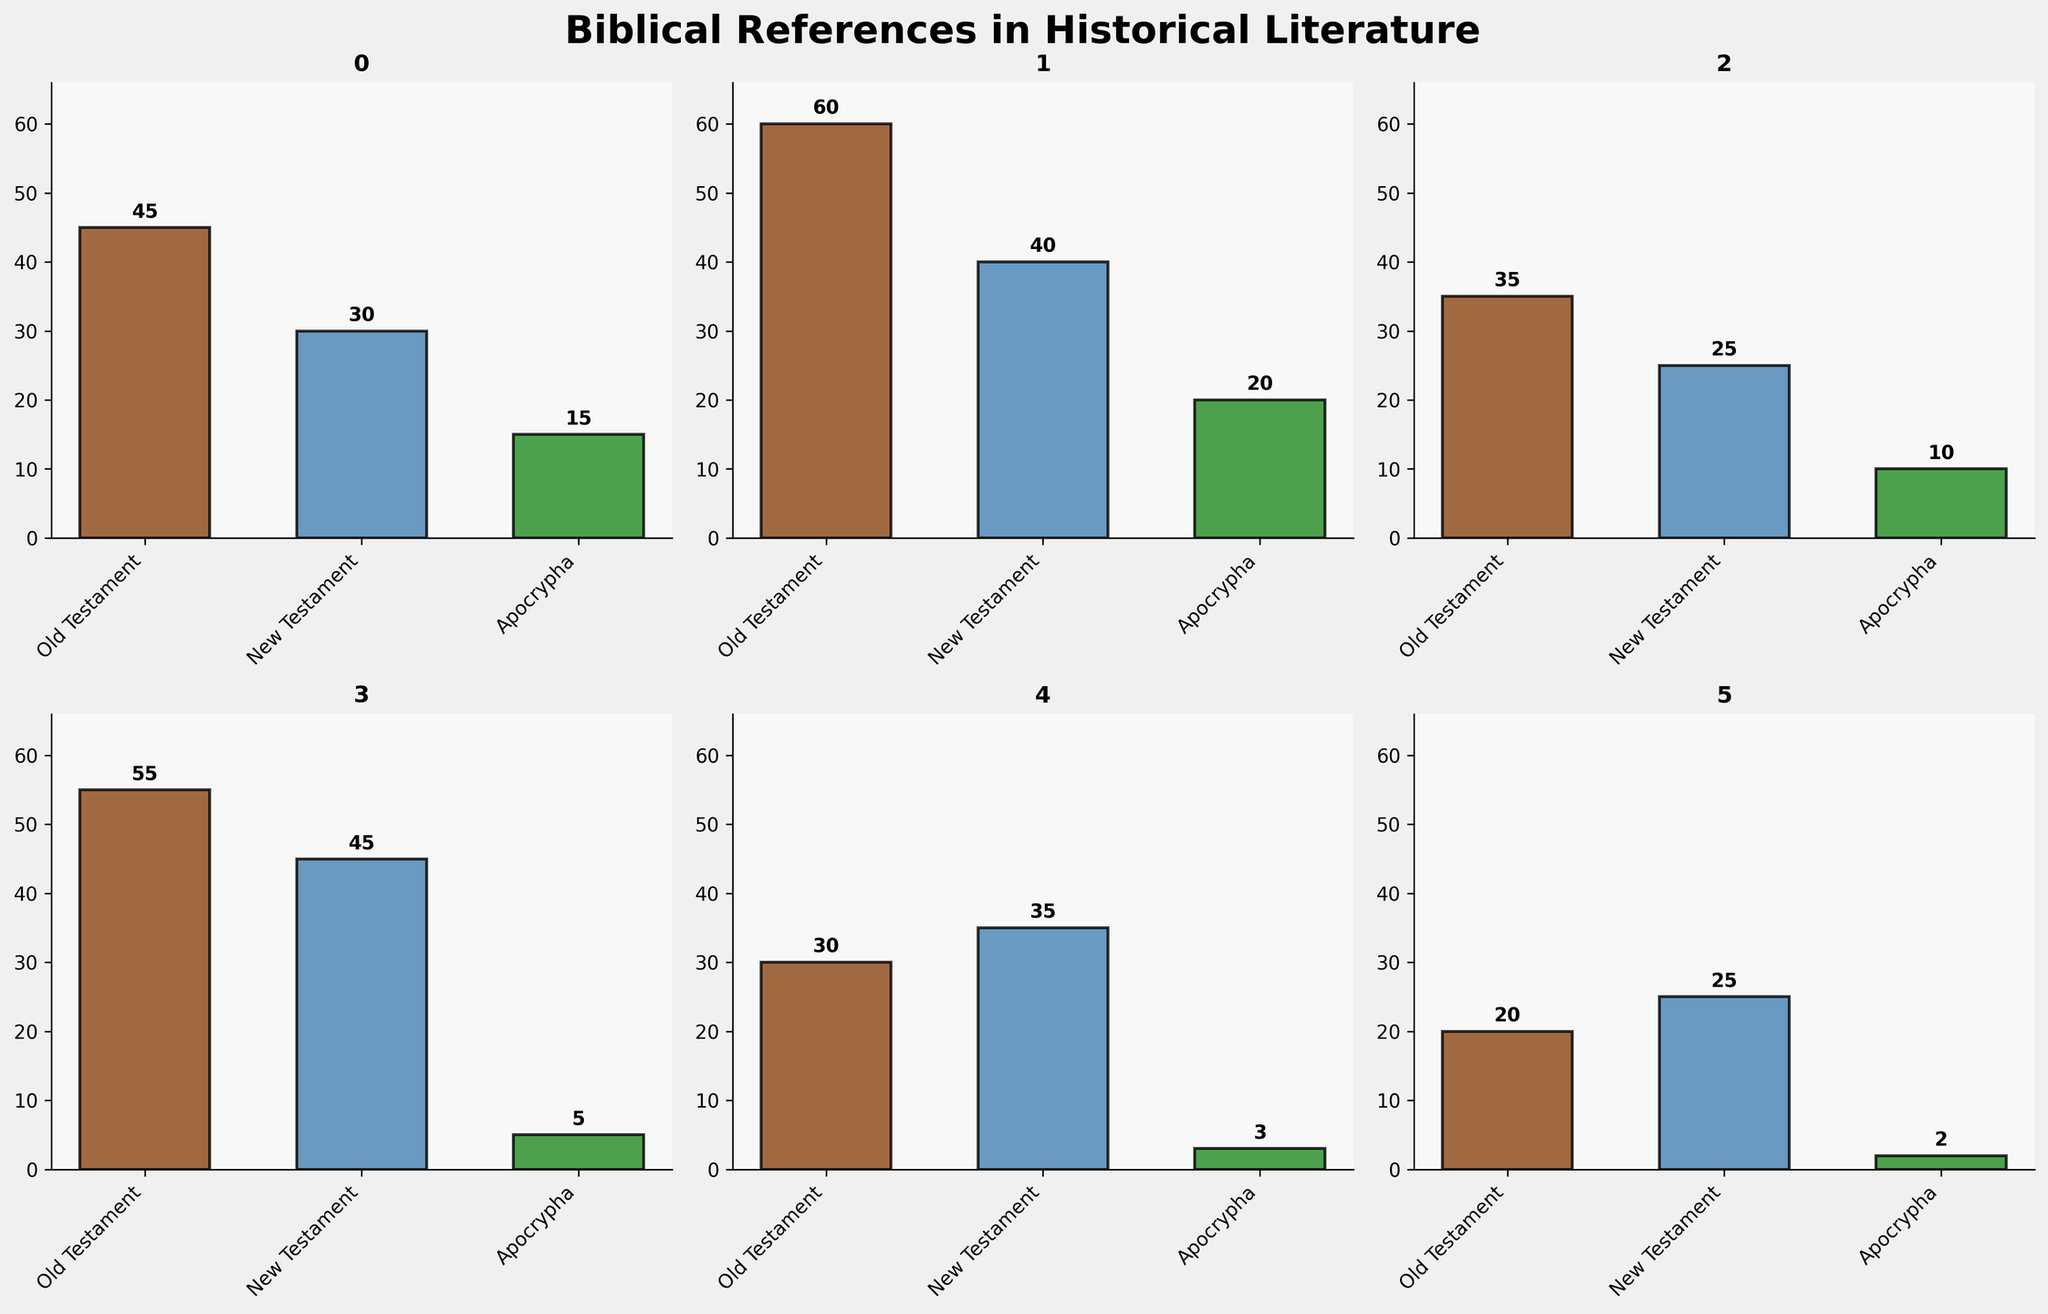Which time period has the highest frequency of Old Testament references? The bar chart shows that the Renaissance period has the highest frequency of Old Testament references with a value of 60.
Answer: Renaissance (1500-1600) Which book group has the lowest reference frequency in the Contemporary period? By examining the subplots for the Contemporary period, the Apocrypha has the lowest reference frequency with a value of 2.
Answer: Apocrypha How does the frequency of New Testament references in the Enlightenment period compare to the frequency in the Victorian Era? The bar charts show that the New Testament references have a frequency of 25 in the Enlightenment period and 45 in the Victorian Era, making it higher in the Victorian Era.
Answer: Victorian Era What is the average frequency of all biblical references in the Modern period? In the Modern period, the frequencies are Old Testament: 30, New Testament: 35, Apocrypha: 3. Summing them gives 68, and the average is 68/3 = 22.67.
Answer: 22.67 Which period shows the greatest decrease in Old Testament references compared to the previous period? By comparing each period, the largest decrease in Old Testament references occurs between the Victorian Era (55) and Modern period (30), a decrease of 25.
Answer: Modern (1900-2000) In which period is the Apocrypha referencing the most frequent, and how many instances are there? The bar chart reveals that the Renaissance period has the highest frequency of Apocrypha references, totaling 20 instances.
Answer: Renaissance (1500-1600) What is the total frequency of biblical references (all categories combined) in the Medieval period? For the Medieval period, the frequencies are Old Testament: 45, New Testament: 30, Apocrypha: 15. Adding them gives 45 + 30 + 15 = 90.
Answer: 90 Is the frequency of Old Testament references greater in the Victorian Era or in the Contemporary period, and by how much? The Victorian Era has 55 Old Testament references compared to 20 in the Contemporary period. The difference is 55 - 20 = 35.
Answer: Victorian Era by 35 